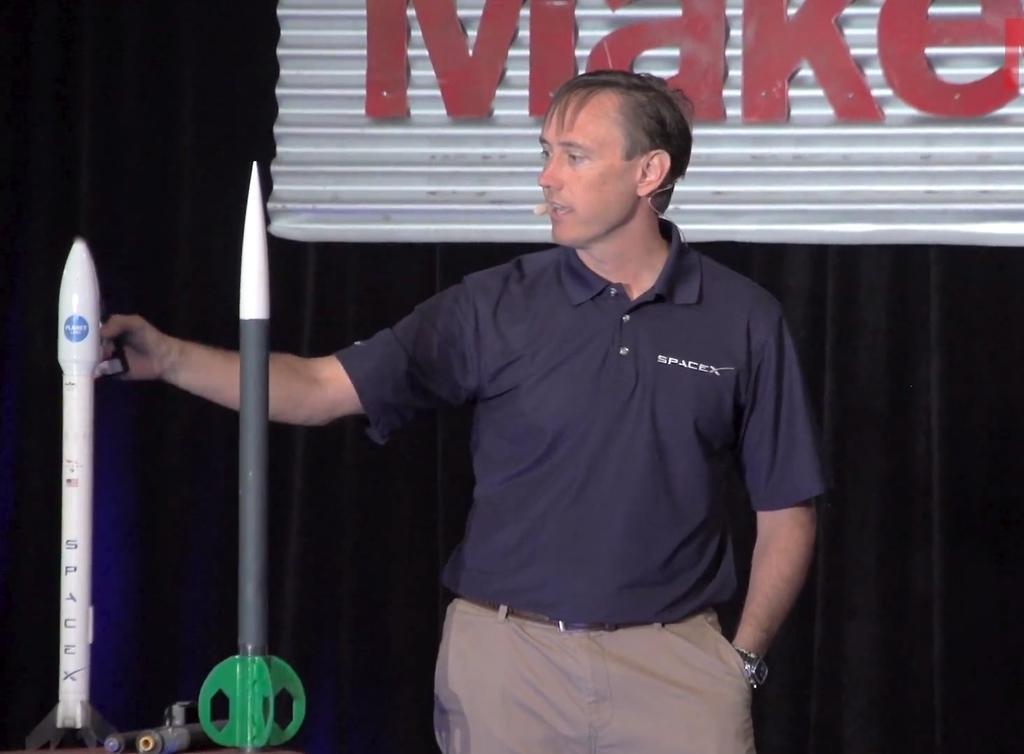Please provide a concise description of this image. In this picture I can observe a man standing in the middle of the picture. On the left side I can observe two objects which are looking like sample rockets. In the background I can observe black color curtain. 